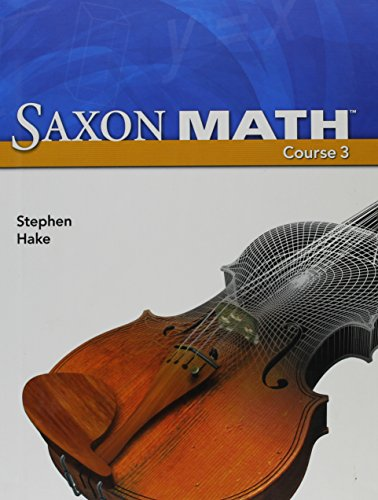What mathematical concepts might be covered in this book? The book likely covers a range of middle school math topics such as algebra, geometry, fractions, and possibly introductory statistics or probability. 